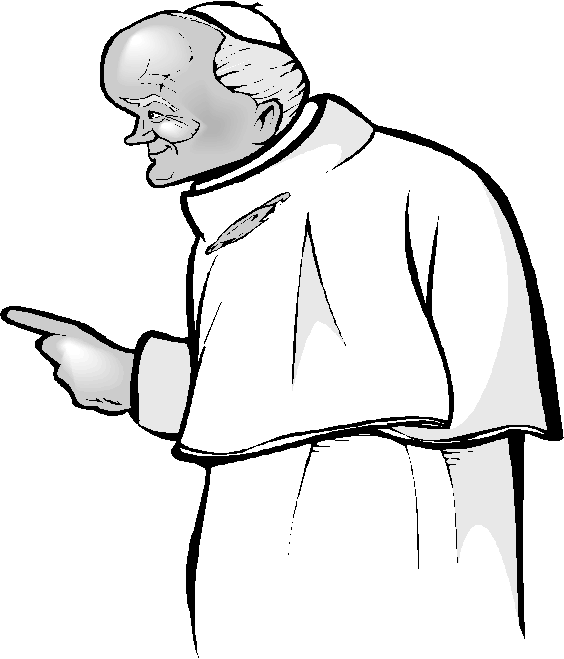Describe the setting where this figure might be, based on his appearance. Given the figure's appearance, he might be situated in a grand hall or an ancient temple, surrounded by ornate architecture and symbols of wisdom and authority. The setting could include high ceilings, tall pillars, and walls adorned with tapestries or frescoes depicting historical events or religious iconography. The atmosphere would be solemn, with an air of reverence and significance. What could be the significance of this moment captured in the image? This moment could represent a pivotal point in a ceremonial event or a significant announcement. The figure's commanding gesture and solemn expression suggest he might be addressing an audience, delivering a profound message, or giving a crucial directive. The significance of this moment lies in the impact of his words and actions, possibly marking a turning point in a religious, academic, or societal context. If this figure were a character in a mythological story, what legendary events might he be involved in? If this figure were a character in a mythological story, he might be a revered oracle who foretold the rise and fall of great empires. He could have been involved in legendary events such as guiding heroes on their quests, deciphering ancient prophecies, and mediating between gods and mortals. His wisdom and knowledge would make him a central figure in tales of great battles, divine interventions, and the timeless struggle between good and evil. Could the figure's intense expression imply internal conflict or emotion? Please elaborate. The figure's intense expression could indeed suggest internal conflict or strong emotions. His furrowed brow and piercing gaze might indicate a deep sense of responsibility or the weight of difficult decisions. Perhaps he is contemplating moral dilemmas, the consequences of his actions, or the burdens of his position. This internal struggle adds depth to his character, portraying him as not just a figure of authority but also someone grappling with the complexities of leadership and wisdom. 